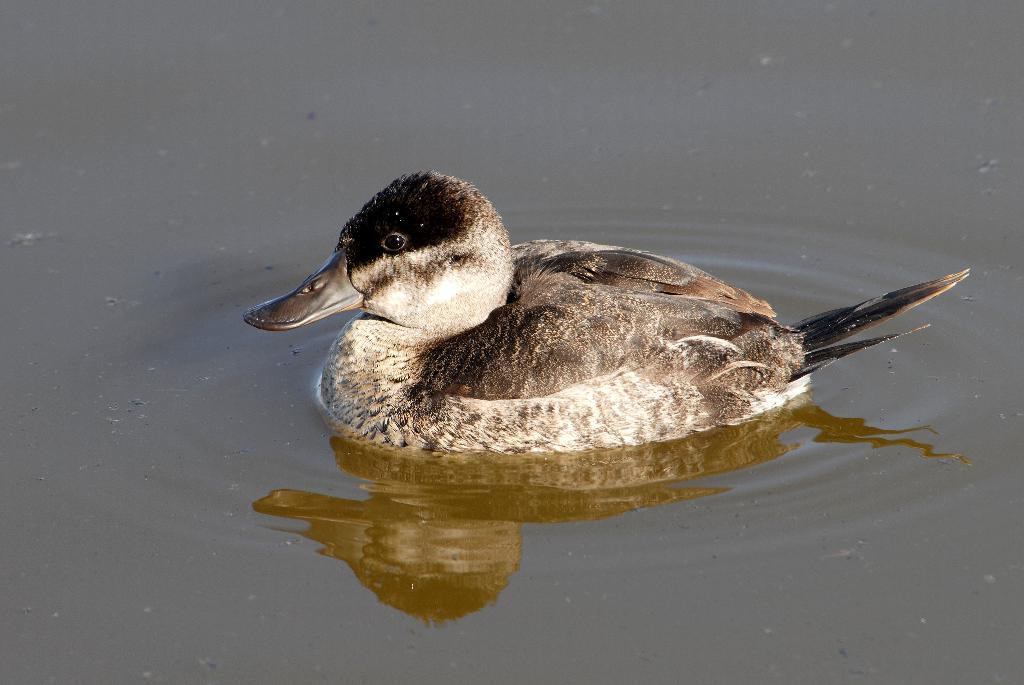What type of animal is in the image? There is a bird in the image. Where is the bird located in the image? The bird is in water. What type of trade is being conducted in the image? There is no trade being conducted in the image; it features a bird in water. What type of pollution can be seen in the image? There is no pollution visible in the image; it features a bird in water. 